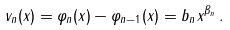<formula> <loc_0><loc_0><loc_500><loc_500>v _ { n } ( x ) = \varphi _ { n } ( x ) - \varphi _ { n - 1 } ( x ) = b _ { n } x ^ { \beta _ { n } } \, .</formula> 